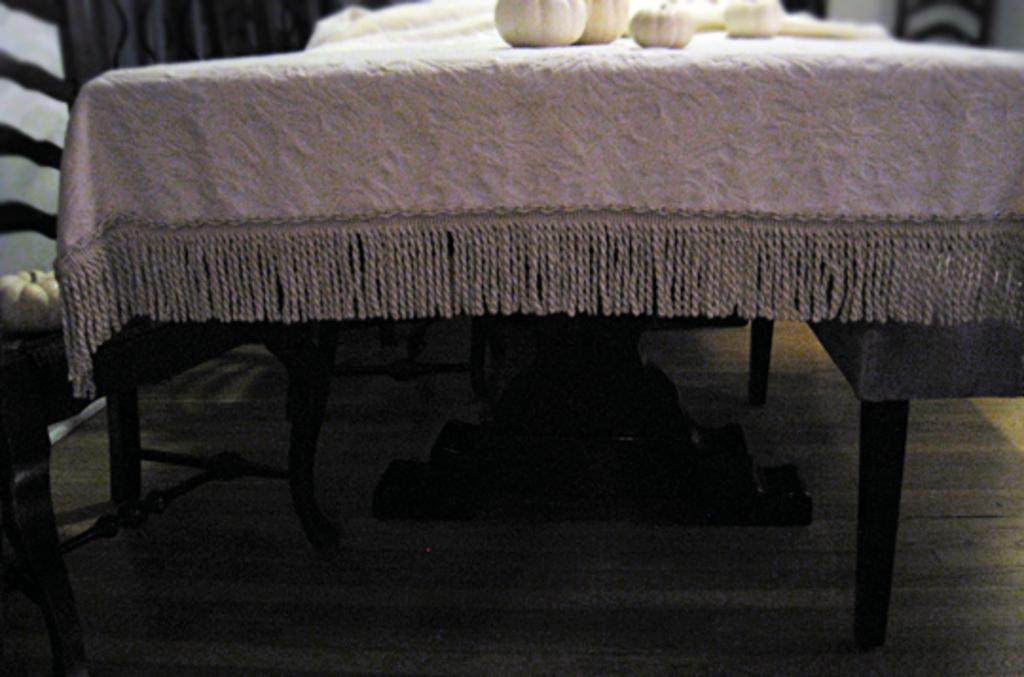What types of food items are visible in the image? Unfortunately, the provided facts do not specify the types of food items in the image. What is covering the table in the image? There is a white cloth on the table in the image. How does the clam feel about the winter season in the image? There is no clam present in the image, so it is not possible to determine how a clam might feel about the winter season. 